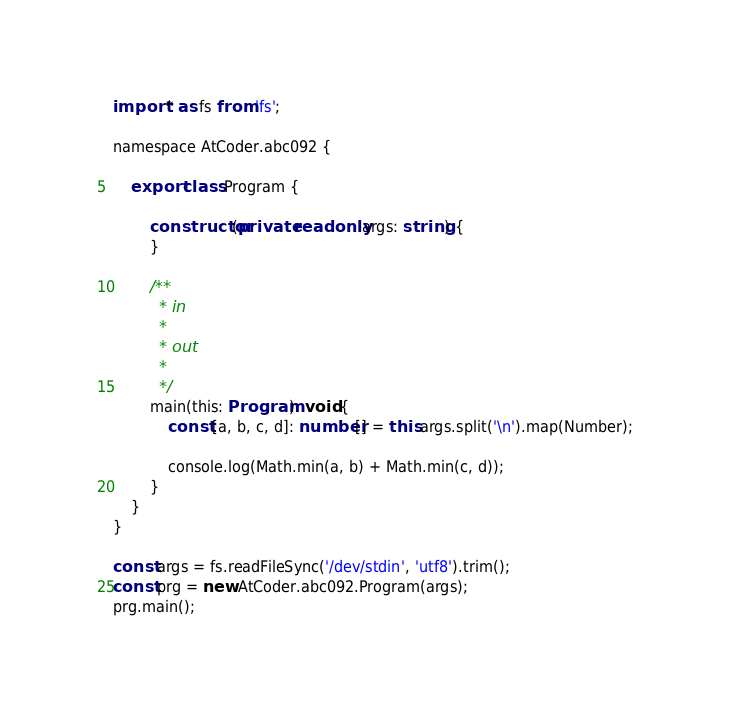Convert code to text. <code><loc_0><loc_0><loc_500><loc_500><_TypeScript_>import * as fs from 'fs';

namespace AtCoder.abc092 {

    export class Program {

        constructor(private readonly args: string) {
        }

        /**
         * in
         *
         * out
         *
         */
        main(this: Program): void {
            const [a, b, c, d]: number[] = this.args.split('\n').map(Number);

            console.log(Math.min(a, b) + Math.min(c, d));
        }
    }
}

const args = fs.readFileSync('/dev/stdin', 'utf8').trim();
const prg = new AtCoder.abc092.Program(args);
prg.main();
</code> 